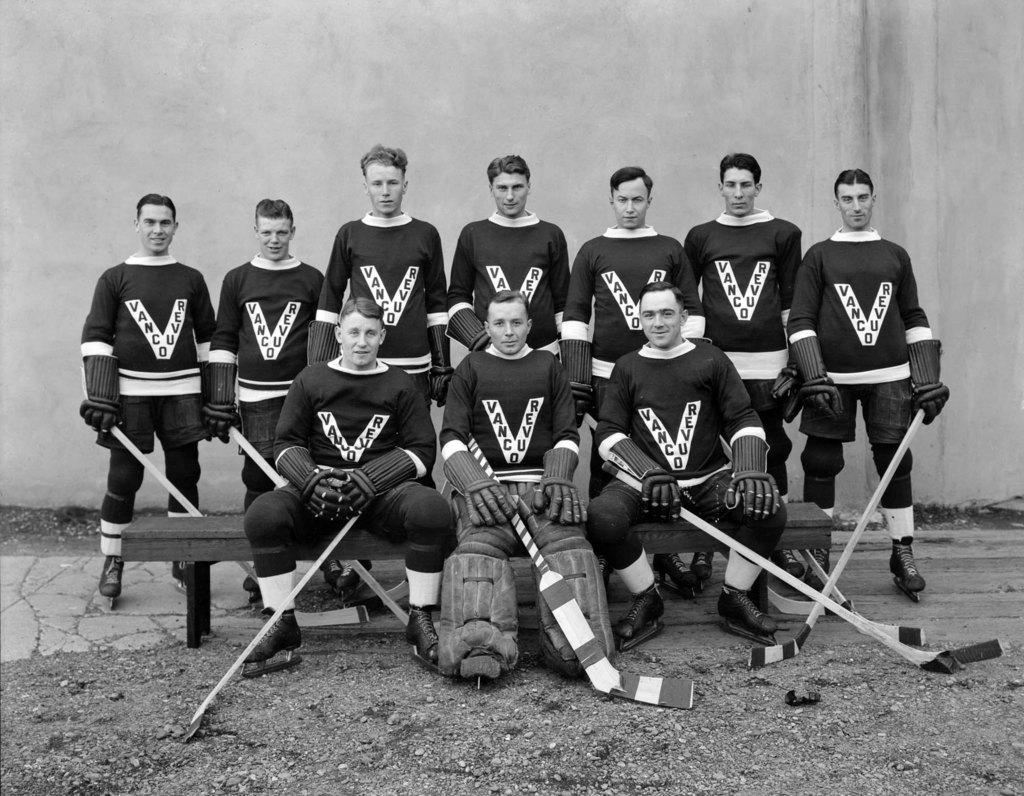<image>
Relay a brief, clear account of the picture shown. hockey players that are wearing jerseys that say 'vancouver' 